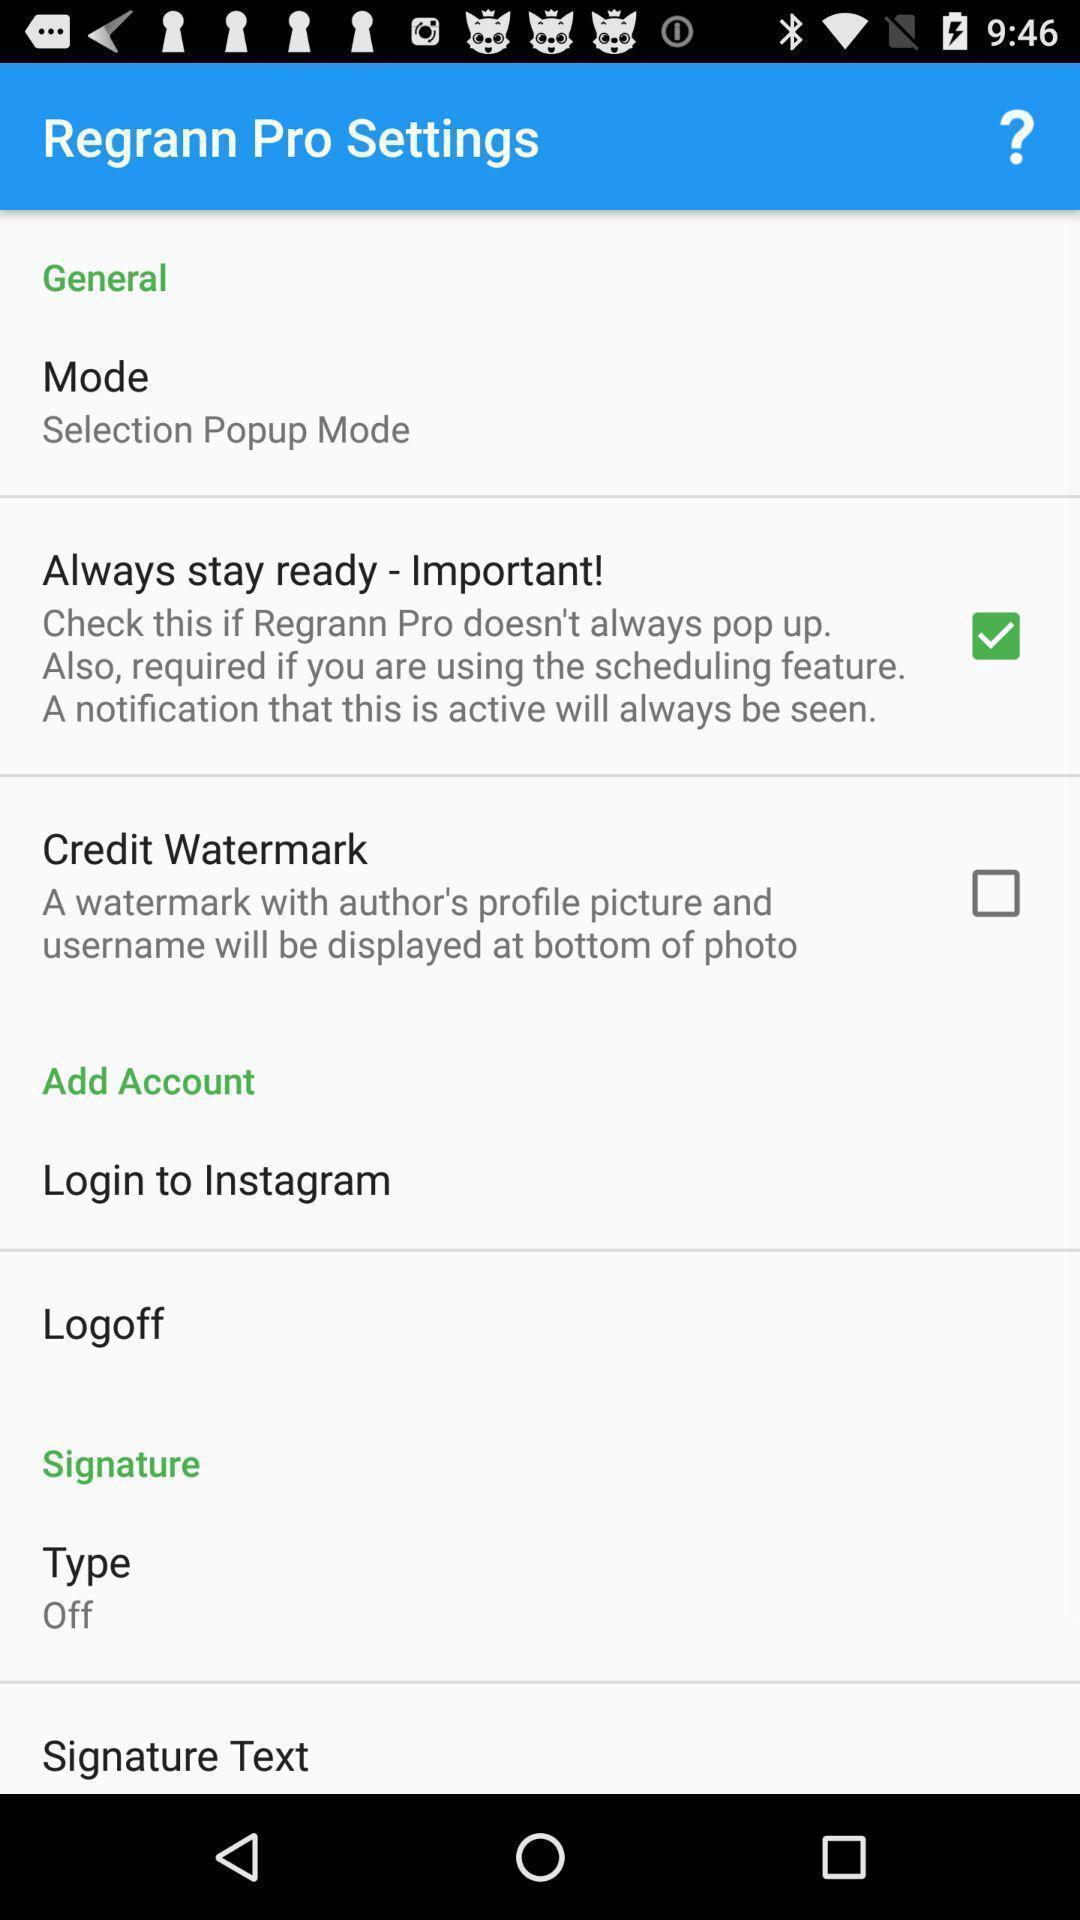What can you discern from this picture? Settings page with options in the social media monitoring app. 